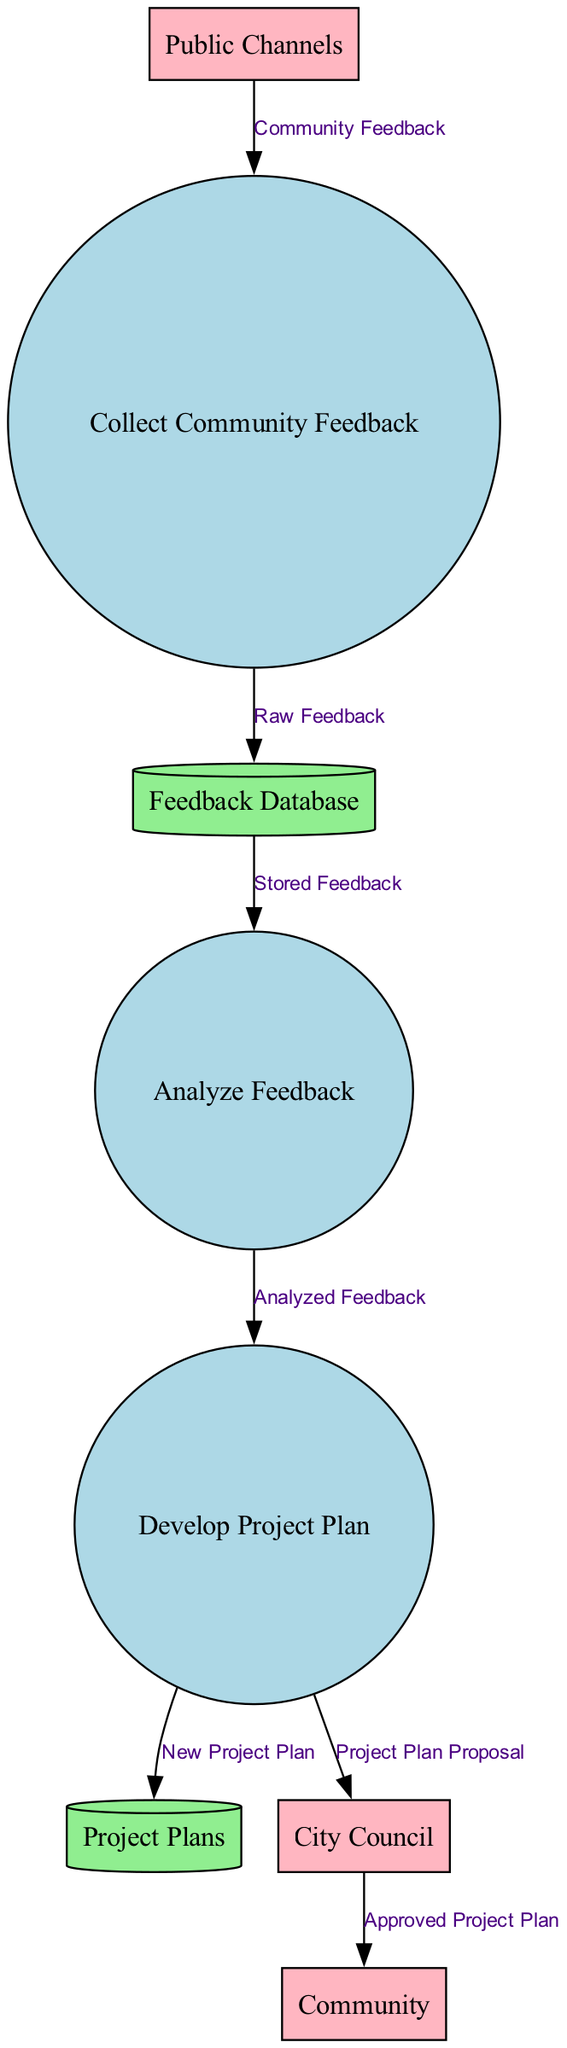What is the first process in the community feedback collection? The diagram starts with the "Collect Community Feedback" process, which is the initial step in the data flow.
Answer: Collect Community Feedback How many data stores are present in the diagram? Upon examining the diagram, there are two data stores: "Feedback Database" and "Project Plans," which indicates that there are two data stores in total.
Answer: 2 What type of external entity is represented by the "Public Channels"? The "Public Channels" is classified as a type of external entity that is the source for collecting community feedback.
Answer: External entity Which process directly feeds into the "Project Plans" data store? The "Develop Project Plan" process produces data that is directly stored in the "Project Plans" data store, indicating a direct flow from this process to the data store.
Answer: Develop Project Plan What data flow originates from the "City Council"? The "City Council" sends out "Approved Project Plan" to the "Community," representing the flow of approved plans back to the citizens.
Answer: Approved Project Plan What is the last step in the community feedback collection process? The last step is proposing the "Project Plan Proposal" from the "Develop Project Plan" process to the "City Council" for approval, marking the end of this process sequence.
Answer: Project Plan Proposal How many processes are involved in this feedback collection process? There are three main processes depicted in the diagram, which are "Collect Community Feedback," "Analyze Feedback," and "Develop Project Plan."
Answer: 3 What data is stored in the "Feedback Database"? The "Feedback Database" stores "Raw Feedback," which consists of all the feedback that has been collected from the community.
Answer: Raw Feedback What is the purpose of the "Analyze Feedback" process? The "Analyze Feedback" process evaluates and interprets the data collected from the community, suggesting its role is critical for understanding community input.
Answer: Evaluate and interpret feedback 